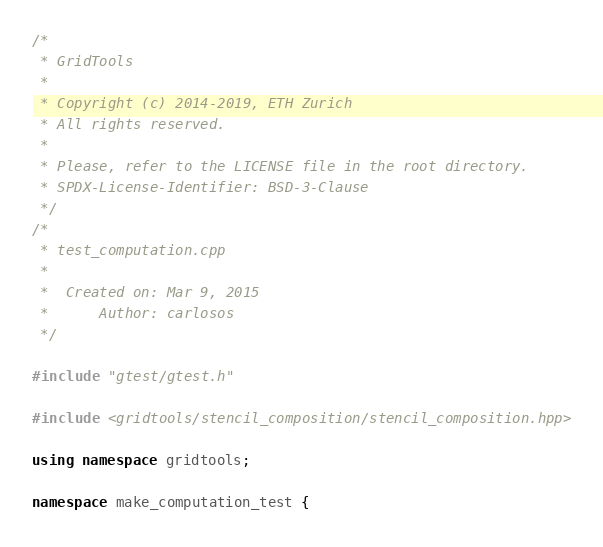Convert code to text. <code><loc_0><loc_0><loc_500><loc_500><_C++_>/*
 * GridTools
 *
 * Copyright (c) 2014-2019, ETH Zurich
 * All rights reserved.
 *
 * Please, refer to the LICENSE file in the root directory.
 * SPDX-License-Identifier: BSD-3-Clause
 */
/*
 * test_computation.cpp
 *
 *  Created on: Mar 9, 2015
 *      Author: carlosos
 */

#include "gtest/gtest.h"

#include <gridtools/stencil_composition/stencil_composition.hpp>

using namespace gridtools;

namespace make_computation_test {</code> 